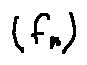Convert formula to latex. <formula><loc_0><loc_0><loc_500><loc_500>( f _ { n } )</formula> 